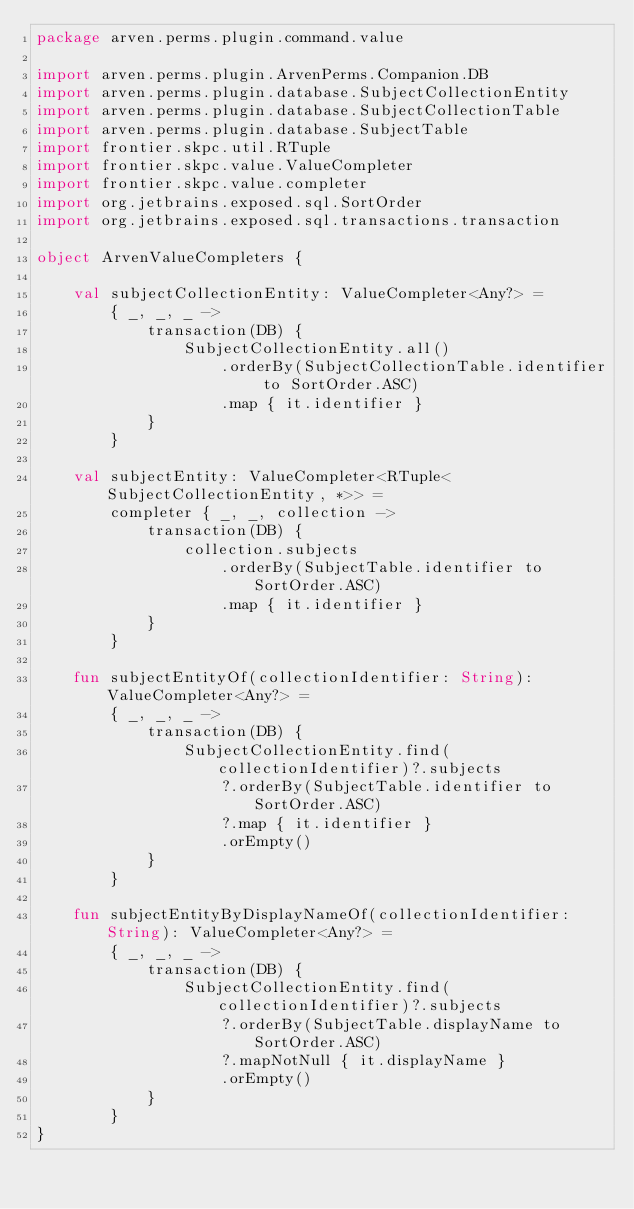<code> <loc_0><loc_0><loc_500><loc_500><_Kotlin_>package arven.perms.plugin.command.value

import arven.perms.plugin.ArvenPerms.Companion.DB
import arven.perms.plugin.database.SubjectCollectionEntity
import arven.perms.plugin.database.SubjectCollectionTable
import arven.perms.plugin.database.SubjectTable
import frontier.skpc.util.RTuple
import frontier.skpc.value.ValueCompleter
import frontier.skpc.value.completer
import org.jetbrains.exposed.sql.SortOrder
import org.jetbrains.exposed.sql.transactions.transaction

object ArvenValueCompleters {

    val subjectCollectionEntity: ValueCompleter<Any?> =
        { _, _, _ ->
            transaction(DB) {
                SubjectCollectionEntity.all()
                    .orderBy(SubjectCollectionTable.identifier to SortOrder.ASC)
                    .map { it.identifier }
            }
        }

    val subjectEntity: ValueCompleter<RTuple<SubjectCollectionEntity, *>> =
        completer { _, _, collection ->
            transaction(DB) {
                collection.subjects
                    .orderBy(SubjectTable.identifier to SortOrder.ASC)
                    .map { it.identifier }
            }
        }

    fun subjectEntityOf(collectionIdentifier: String): ValueCompleter<Any?> =
        { _, _, _ ->
            transaction(DB) {
                SubjectCollectionEntity.find(collectionIdentifier)?.subjects
                    ?.orderBy(SubjectTable.identifier to SortOrder.ASC)
                    ?.map { it.identifier }
                    .orEmpty()
            }
        }

    fun subjectEntityByDisplayNameOf(collectionIdentifier: String): ValueCompleter<Any?> =
        { _, _, _ ->
            transaction(DB) {
                SubjectCollectionEntity.find(collectionIdentifier)?.subjects
                    ?.orderBy(SubjectTable.displayName to SortOrder.ASC)
                    ?.mapNotNull { it.displayName }
                    .orEmpty()
            }
        }
}</code> 